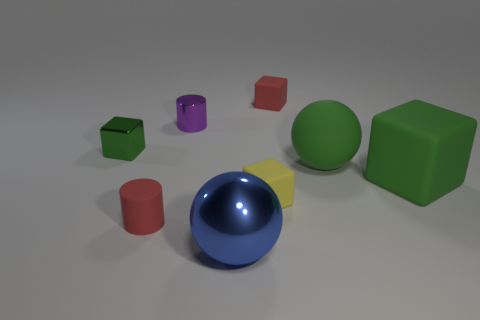The other tiny rubber object that is the same shape as the tiny yellow rubber object is what color?
Your answer should be compact. Red. Is there any other thing that is the same color as the rubber sphere?
Ensure brevity in your answer.  Yes. Does the red block have the same material as the big blue ball?
Your answer should be very brief. No. How many large balls are the same material as the tiny purple cylinder?
Your answer should be compact. 1. There is a metal ball; is it the same size as the red thing in front of the green rubber sphere?
Provide a succinct answer. No. What color is the matte cube that is left of the green matte ball and in front of the matte sphere?
Offer a very short reply. Yellow. There is a red rubber object that is to the left of the red block; are there any tiny things that are to the right of it?
Offer a terse response. Yes. Is the number of red cubes in front of the small green object the same as the number of tiny purple things?
Your answer should be very brief. No. What number of tiny things are to the right of the purple cylinder that is behind the tiny block in front of the green ball?
Provide a short and direct response. 2. Are there any balls that have the same size as the red matte cube?
Your response must be concise. No. 